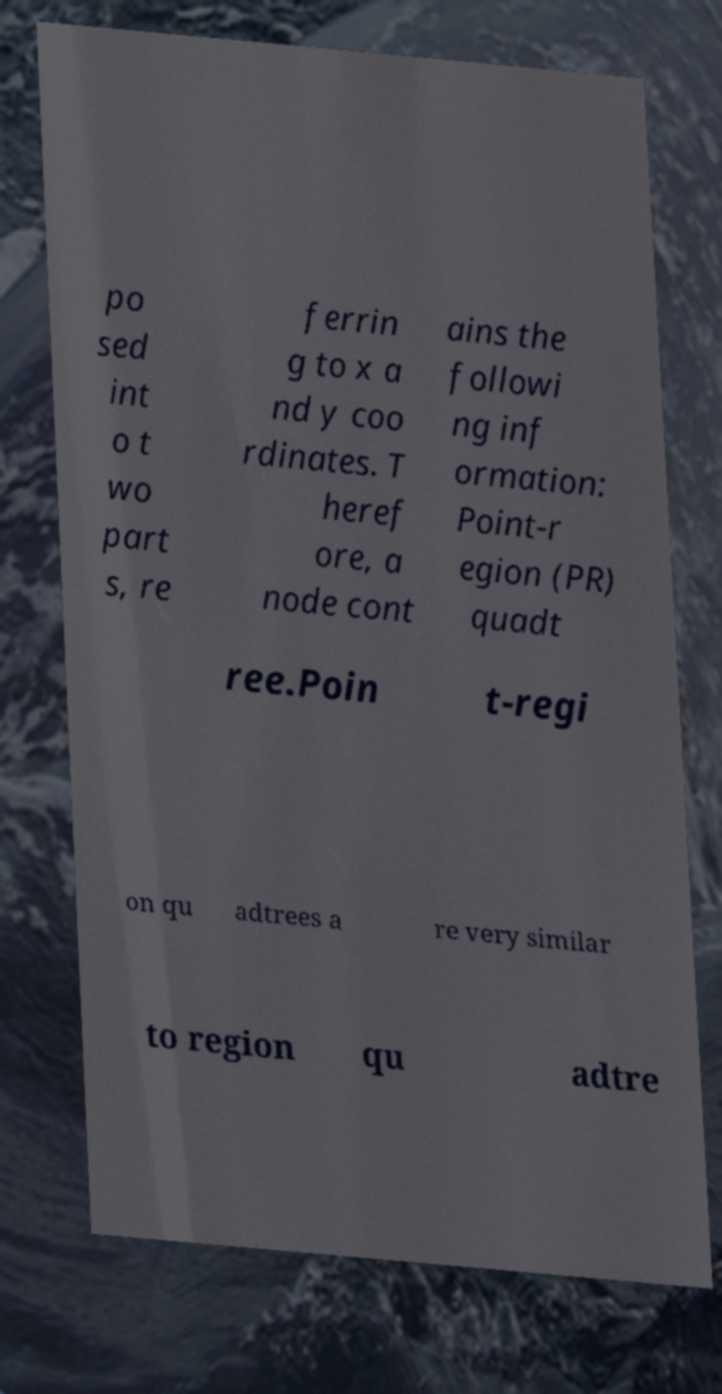For documentation purposes, I need the text within this image transcribed. Could you provide that? po sed int o t wo part s, re ferrin g to x a nd y coo rdinates. T heref ore, a node cont ains the followi ng inf ormation: Point-r egion (PR) quadt ree.Poin t-regi on qu adtrees a re very similar to region qu adtre 